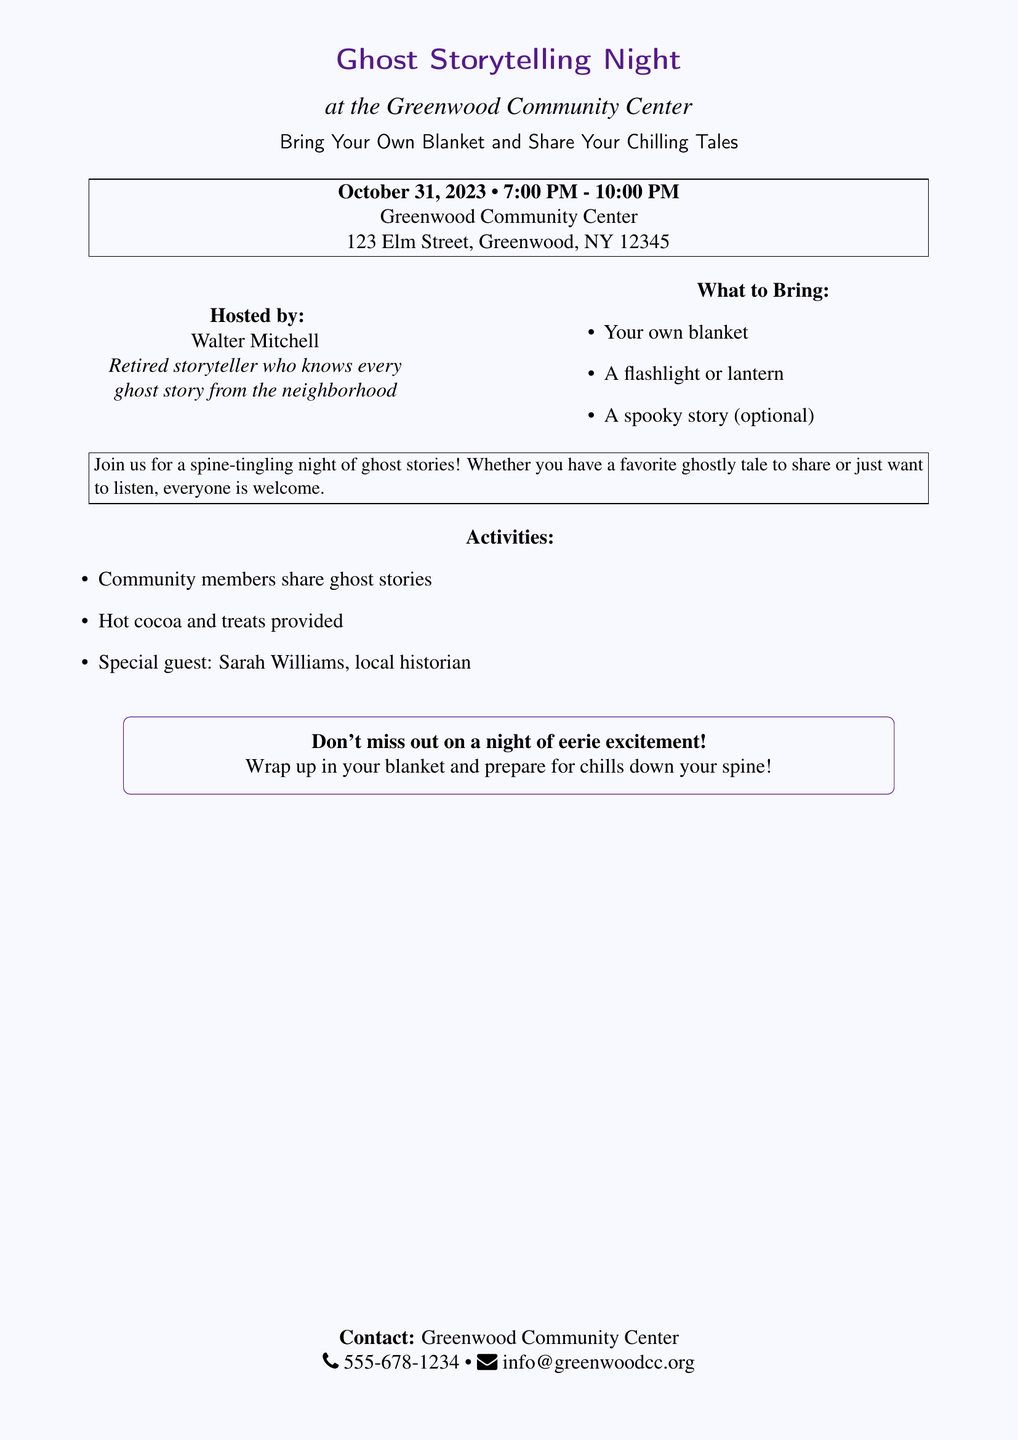What is the date of the event? The date of the event is specified as October 31, 2023.
Answer: October 31, 2023 What time does the storytelling night start? The start time for the event is mentioned in the document as 7:00 PM.
Answer: 7:00 PM Who is the host of the event? The document states that Walter Mitchell is the host of the event.
Answer: Walter Mitchell What is one item attendees are asked to bring? The document lists "Your own blanket" as one of the items to bring.
Answer: Your own blanket What special guest will be present? The flyer mentions that Sarah Williams, a local historian, will be the special guest.
Answer: Sarah Williams How long will the event last? The event runs from 7:00 PM to 10:00 PM, indicating a duration of 3 hours.
Answer: 3 hours What type of beverages will be provided? The document notes that "Hot cocoa" will be provided at the event.
Answer: Hot cocoa What is the location of the event? The location mentioned in the document is Greenwood Community Center at 123 Elm Street.
Answer: Greenwood Community Center What overall theme does the event promote? The event is centered around sharing ghost stories, as highlighted in the title and description.
Answer: Ghost storytelling 